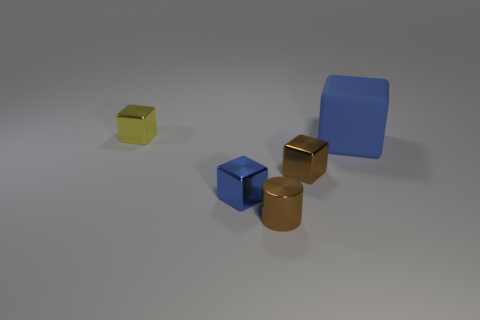Add 1 tiny yellow metallic cubes. How many objects exist? 6 Subtract all cylinders. How many objects are left? 4 Subtract 0 cyan blocks. How many objects are left? 5 Subtract all brown cylinders. Subtract all tiny yellow matte cylinders. How many objects are left? 4 Add 3 small yellow cubes. How many small yellow cubes are left? 4 Add 2 brown cylinders. How many brown cylinders exist? 3 